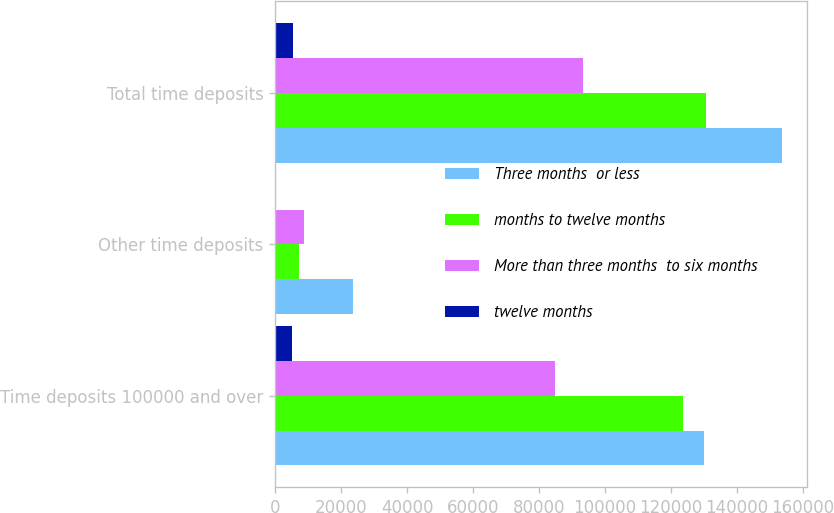Convert chart. <chart><loc_0><loc_0><loc_500><loc_500><stacked_bar_chart><ecel><fcel>Time deposits 100000 and over<fcel>Other time deposits<fcel>Total time deposits<nl><fcel>Three months  or less<fcel>130057<fcel>23518<fcel>153575<nl><fcel>months to twelve months<fcel>123479<fcel>7089<fcel>130568<nl><fcel>More than three months  to six months<fcel>84797<fcel>8580<fcel>93377<nl><fcel>twelve months<fcel>5200<fcel>110<fcel>5310<nl></chart> 